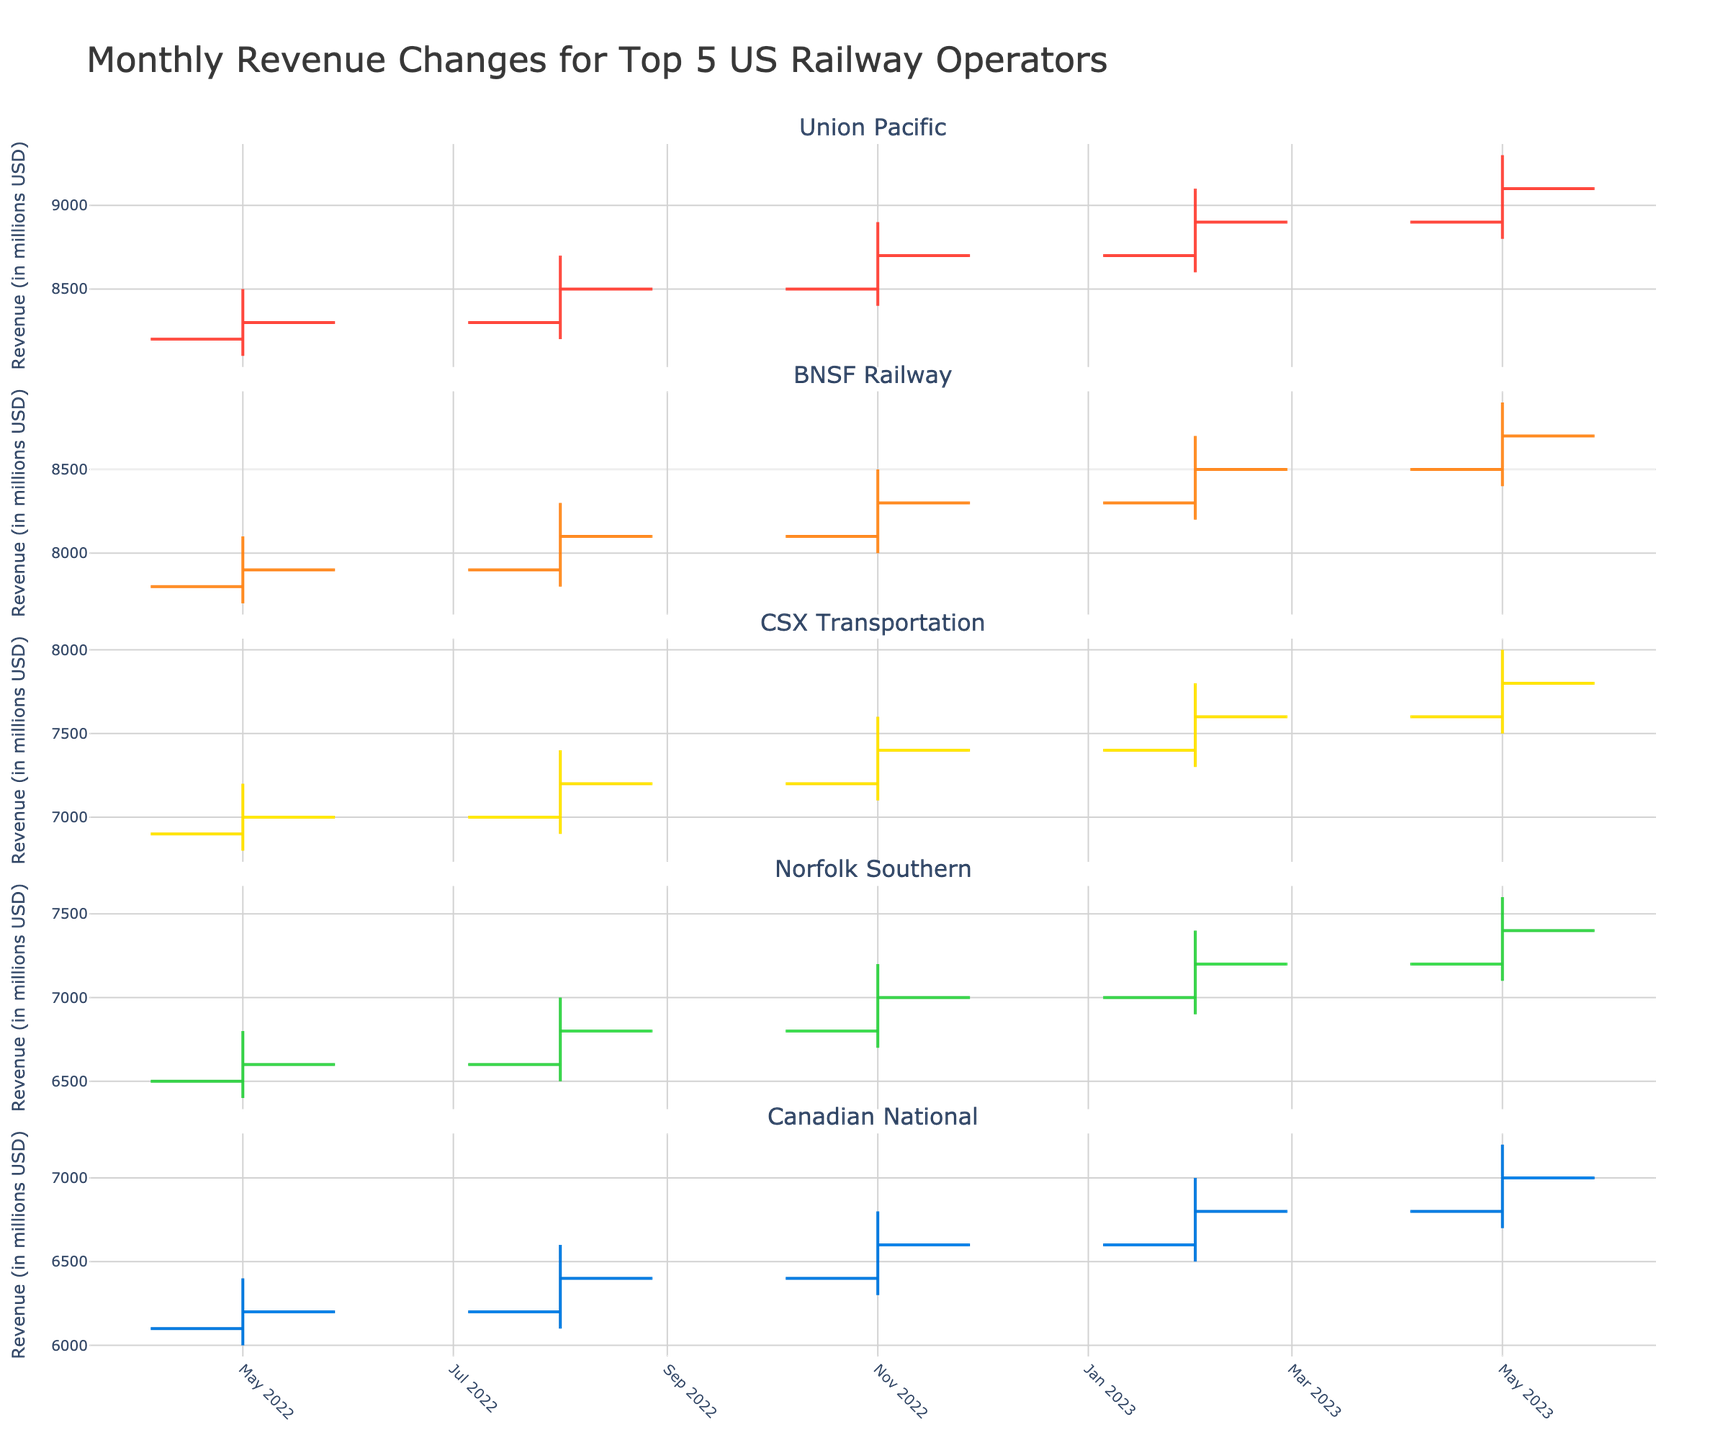What's the title of the chart? The title is written at the top center of the chart, which provides a brief overview of the data being presented. The title is "Monthly Revenue Changes for Top 5 US Railway Operators".
Answer: Monthly Revenue Changes for Top 5 US Railway Operators How many companies are represented in the chart? There is one subplot for each company, and the figure includes 5 different subplots, each with the company name as a subplot title.
Answer: 5 Which company had the highest revenue in May 2023? Look at the subplots for the revenue values in May 2023 and identify the highest closing price among the companies. Union Pacific, with a closing value of 9100, had the highest revenue in May 2023.
Answer: Union Pacific Was there any company that had a consistent increase in revenue every month? Examine each company's trend in quarterly revenues. None of the companies had consistent increases in revenues every quarter without any decreases.
Answer: No What is the total revenue change for BNSF Railway from May 2022 to May 2023? Calculate the difference between the closing revenues of May 2023 and May 2022 for BNSF Railway. The total revenue change is 8700 (May 2023) - 7900 (May 2022) = 800.
Answer: 800 Which company showed the most significant quarterly fluctuation in revenue? Compare the range (high minus low) values of each quarter across all companies and find the one with the largest fluctuation. Union Pacific demonstrated significant fluctuations with ranges like 800 (May 2022), 800 (August 2022), and 800 (May 2023).
Answer: Union Pacific In which month did Canadian National have the lowest revenue? Look at all the data points for the opening and closing prices for Canadian National; the lowest revenue is seen in May 2022, with a value of 6200.
Answer: May 2022 Between Norfolk Southern and CSX Transportation, which one had a higher revenue in February 2023? Compare the closing prices of Norfolk Southern and CSX Transportation for February 2023. CSX Transportation had 7600, and Norfolk Southern had 7200. Therefore, CSX Transportation had a higher revenue.
Answer: CSX Transportation How did the revenue of Union Pacific change from February 2023 to May 2023? Compute the difference between the closing revenues of Union Pacific for February 2023 and May 2023. Union Pacific’s revenue changed from 8900 (Feb 2023) to 9100 (May 2023), resulting in an increase of 200.
Answer: Increase by 200 What month's revenue for CSX Transportation was closest to the high value in November 2022? Look at the high value for November 2022 for CSX Transportation and compare the closest revenue month that matches or is closest to 7600, observing the chart's patterns over time. CSX Transportation's revenue in May 2023 at 7800 is closest to the November 2022 high value of 7600.
Answer: May 2023 